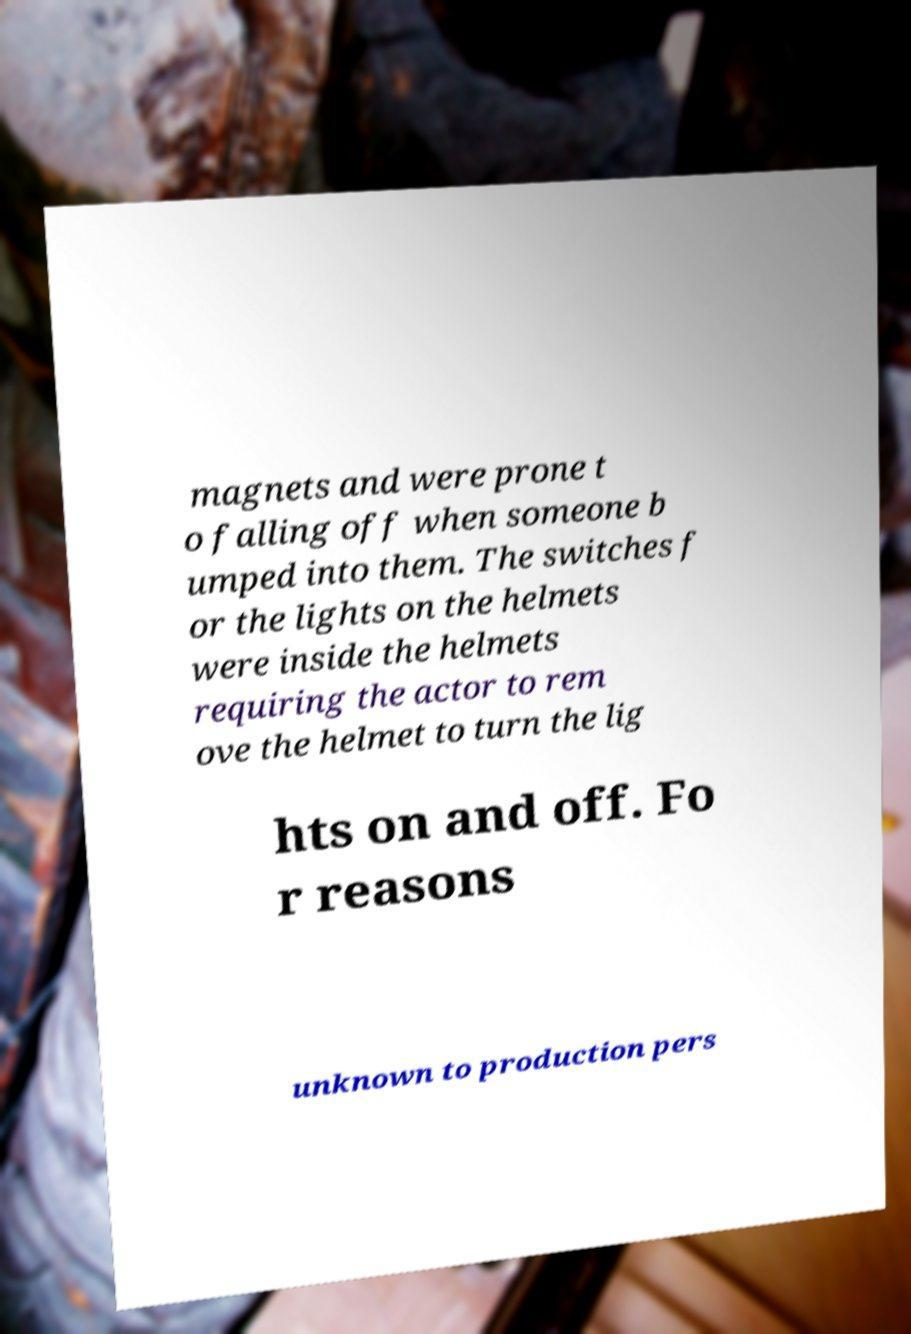For documentation purposes, I need the text within this image transcribed. Could you provide that? magnets and were prone t o falling off when someone b umped into them. The switches f or the lights on the helmets were inside the helmets requiring the actor to rem ove the helmet to turn the lig hts on and off. Fo r reasons unknown to production pers 